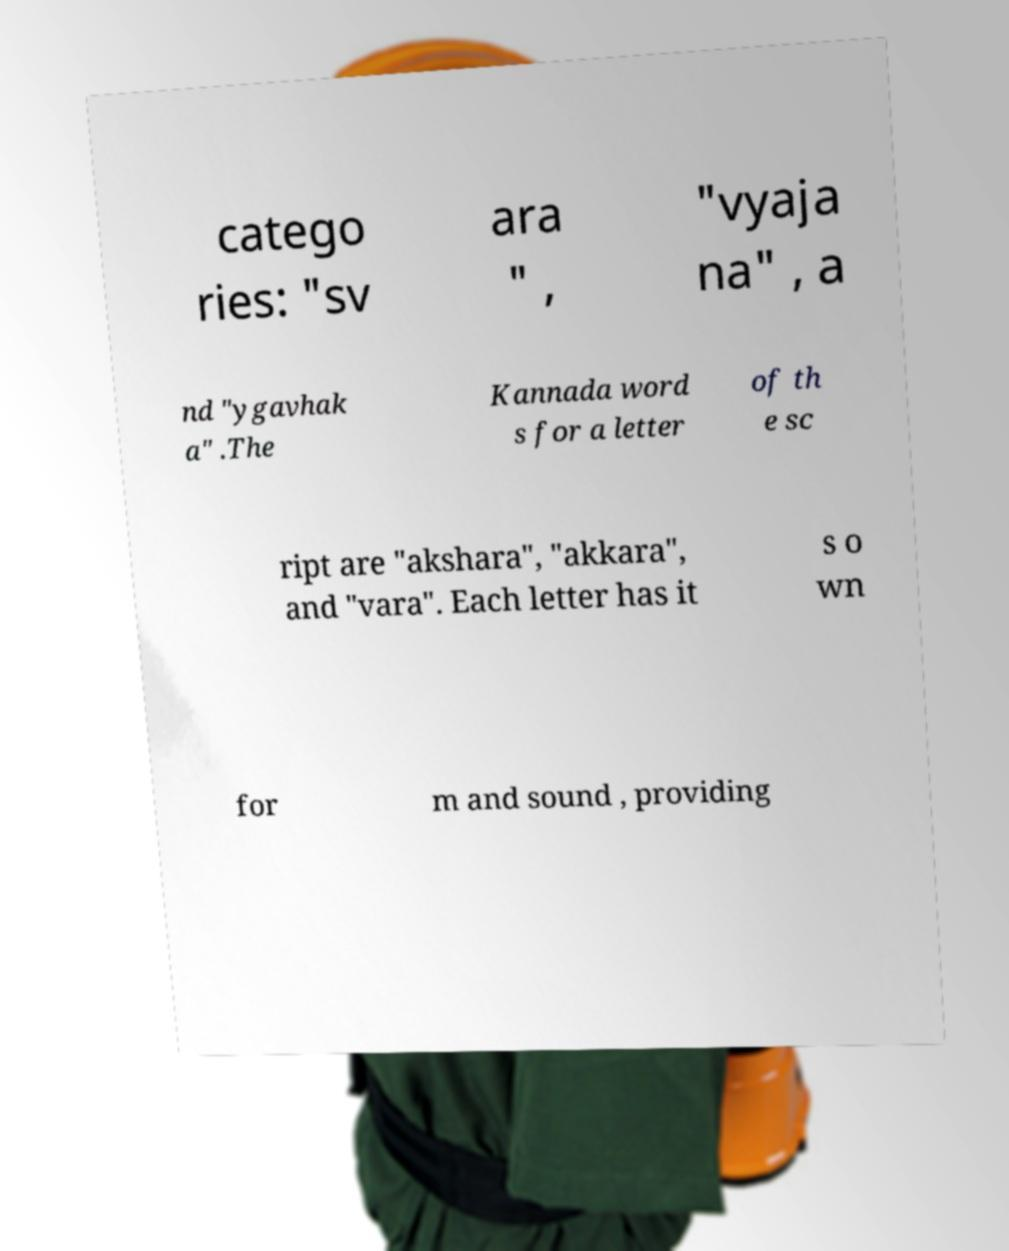Please read and relay the text visible in this image. What does it say? catego ries: "sv ara " , "vyaja na" , a nd "ygavhak a" .The Kannada word s for a letter of th e sc ript are "akshara", "akkara", and "vara". Each letter has it s o wn for m and sound , providing 